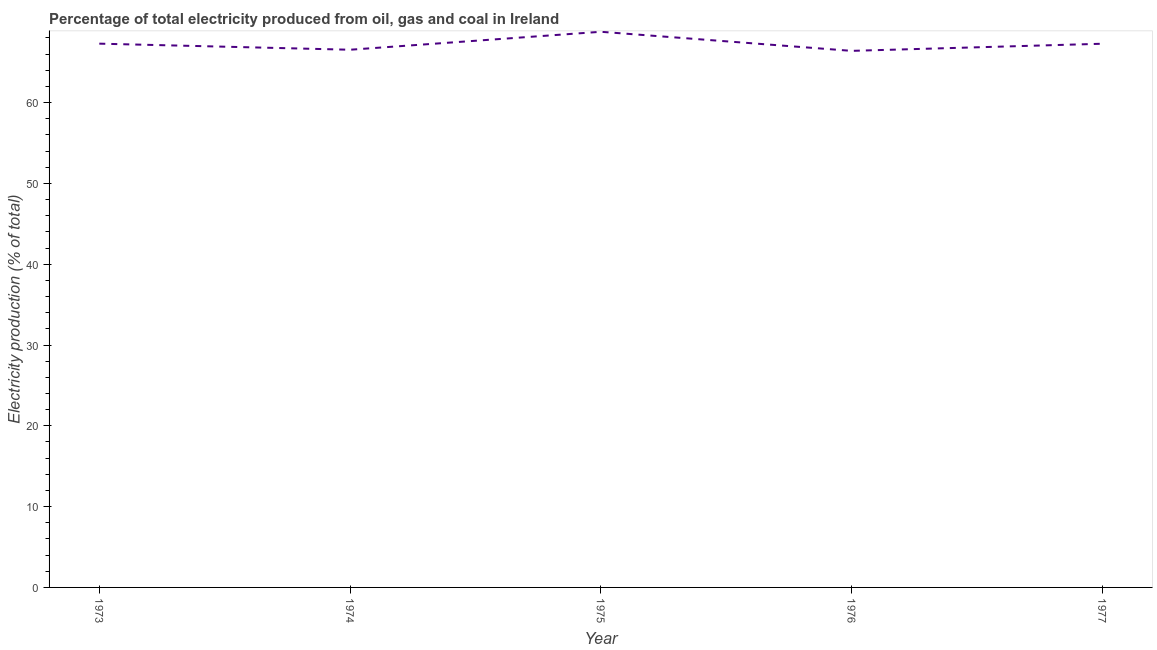What is the electricity production in 1976?
Provide a short and direct response. 66.41. Across all years, what is the maximum electricity production?
Your answer should be very brief. 68.77. Across all years, what is the minimum electricity production?
Make the answer very short. 66.41. In which year was the electricity production maximum?
Provide a short and direct response. 1975. In which year was the electricity production minimum?
Give a very brief answer. 1976. What is the sum of the electricity production?
Offer a terse response. 336.3. What is the difference between the electricity production in 1974 and 1975?
Make the answer very short. -2.22. What is the average electricity production per year?
Your response must be concise. 67.26. What is the median electricity production?
Your response must be concise. 67.29. What is the ratio of the electricity production in 1974 to that in 1977?
Keep it short and to the point. 0.99. Is the electricity production in 1975 less than that in 1976?
Provide a short and direct response. No. Is the difference between the electricity production in 1976 and 1977 greater than the difference between any two years?
Your answer should be compact. No. What is the difference between the highest and the second highest electricity production?
Give a very brief answer. 1.47. What is the difference between the highest and the lowest electricity production?
Your answer should be very brief. 2.36. In how many years, is the electricity production greater than the average electricity production taken over all years?
Provide a succinct answer. 3. Does the electricity production monotonically increase over the years?
Give a very brief answer. No. How many lines are there?
Give a very brief answer. 1. What is the title of the graph?
Provide a succinct answer. Percentage of total electricity produced from oil, gas and coal in Ireland. What is the label or title of the Y-axis?
Your answer should be compact. Electricity production (% of total). What is the Electricity production (% of total) in 1973?
Provide a short and direct response. 67.3. What is the Electricity production (% of total) of 1974?
Offer a very short reply. 66.54. What is the Electricity production (% of total) in 1975?
Your answer should be compact. 68.77. What is the Electricity production (% of total) in 1976?
Give a very brief answer. 66.41. What is the Electricity production (% of total) in 1977?
Keep it short and to the point. 67.29. What is the difference between the Electricity production (% of total) in 1973 and 1974?
Make the answer very short. 0.75. What is the difference between the Electricity production (% of total) in 1973 and 1975?
Your answer should be compact. -1.47. What is the difference between the Electricity production (% of total) in 1973 and 1976?
Keep it short and to the point. 0.89. What is the difference between the Electricity production (% of total) in 1973 and 1977?
Your answer should be compact. 0.01. What is the difference between the Electricity production (% of total) in 1974 and 1975?
Your answer should be very brief. -2.22. What is the difference between the Electricity production (% of total) in 1974 and 1976?
Your answer should be compact. 0.14. What is the difference between the Electricity production (% of total) in 1974 and 1977?
Make the answer very short. -0.74. What is the difference between the Electricity production (% of total) in 1975 and 1976?
Give a very brief answer. 2.36. What is the difference between the Electricity production (% of total) in 1975 and 1977?
Offer a very short reply. 1.48. What is the difference between the Electricity production (% of total) in 1976 and 1977?
Offer a terse response. -0.88. What is the ratio of the Electricity production (% of total) in 1973 to that in 1974?
Give a very brief answer. 1.01. What is the ratio of the Electricity production (% of total) in 1973 to that in 1976?
Your answer should be compact. 1.01. What is the ratio of the Electricity production (% of total) in 1973 to that in 1977?
Ensure brevity in your answer.  1. What is the ratio of the Electricity production (% of total) in 1975 to that in 1976?
Make the answer very short. 1.04. What is the ratio of the Electricity production (% of total) in 1975 to that in 1977?
Your answer should be very brief. 1.02. What is the ratio of the Electricity production (% of total) in 1976 to that in 1977?
Your answer should be compact. 0.99. 